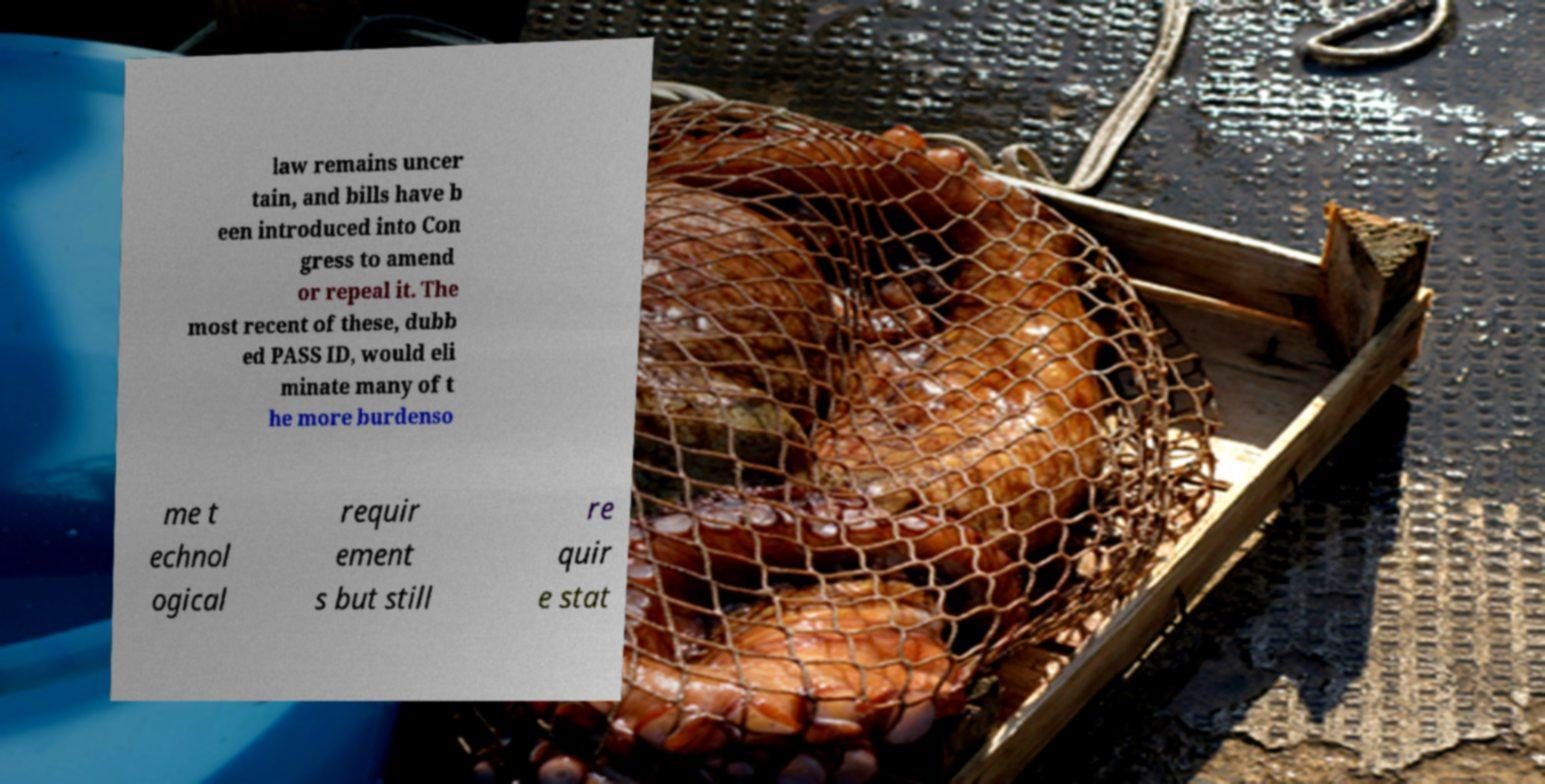Could you extract and type out the text from this image? law remains uncer tain, and bills have b een introduced into Con gress to amend or repeal it. The most recent of these, dubb ed PASS ID, would eli minate many of t he more burdenso me t echnol ogical requir ement s but still re quir e stat 